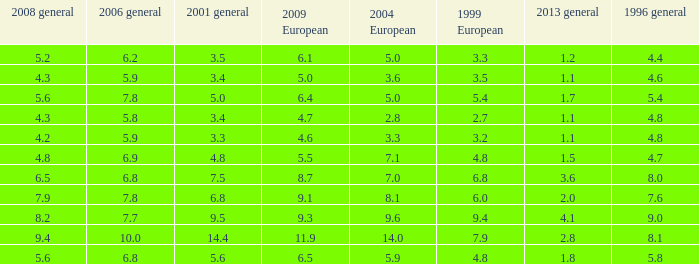What is the lowest value for 2004 European when 1999 European is 3.3 and less than 4.4 in 1996 general? None. 